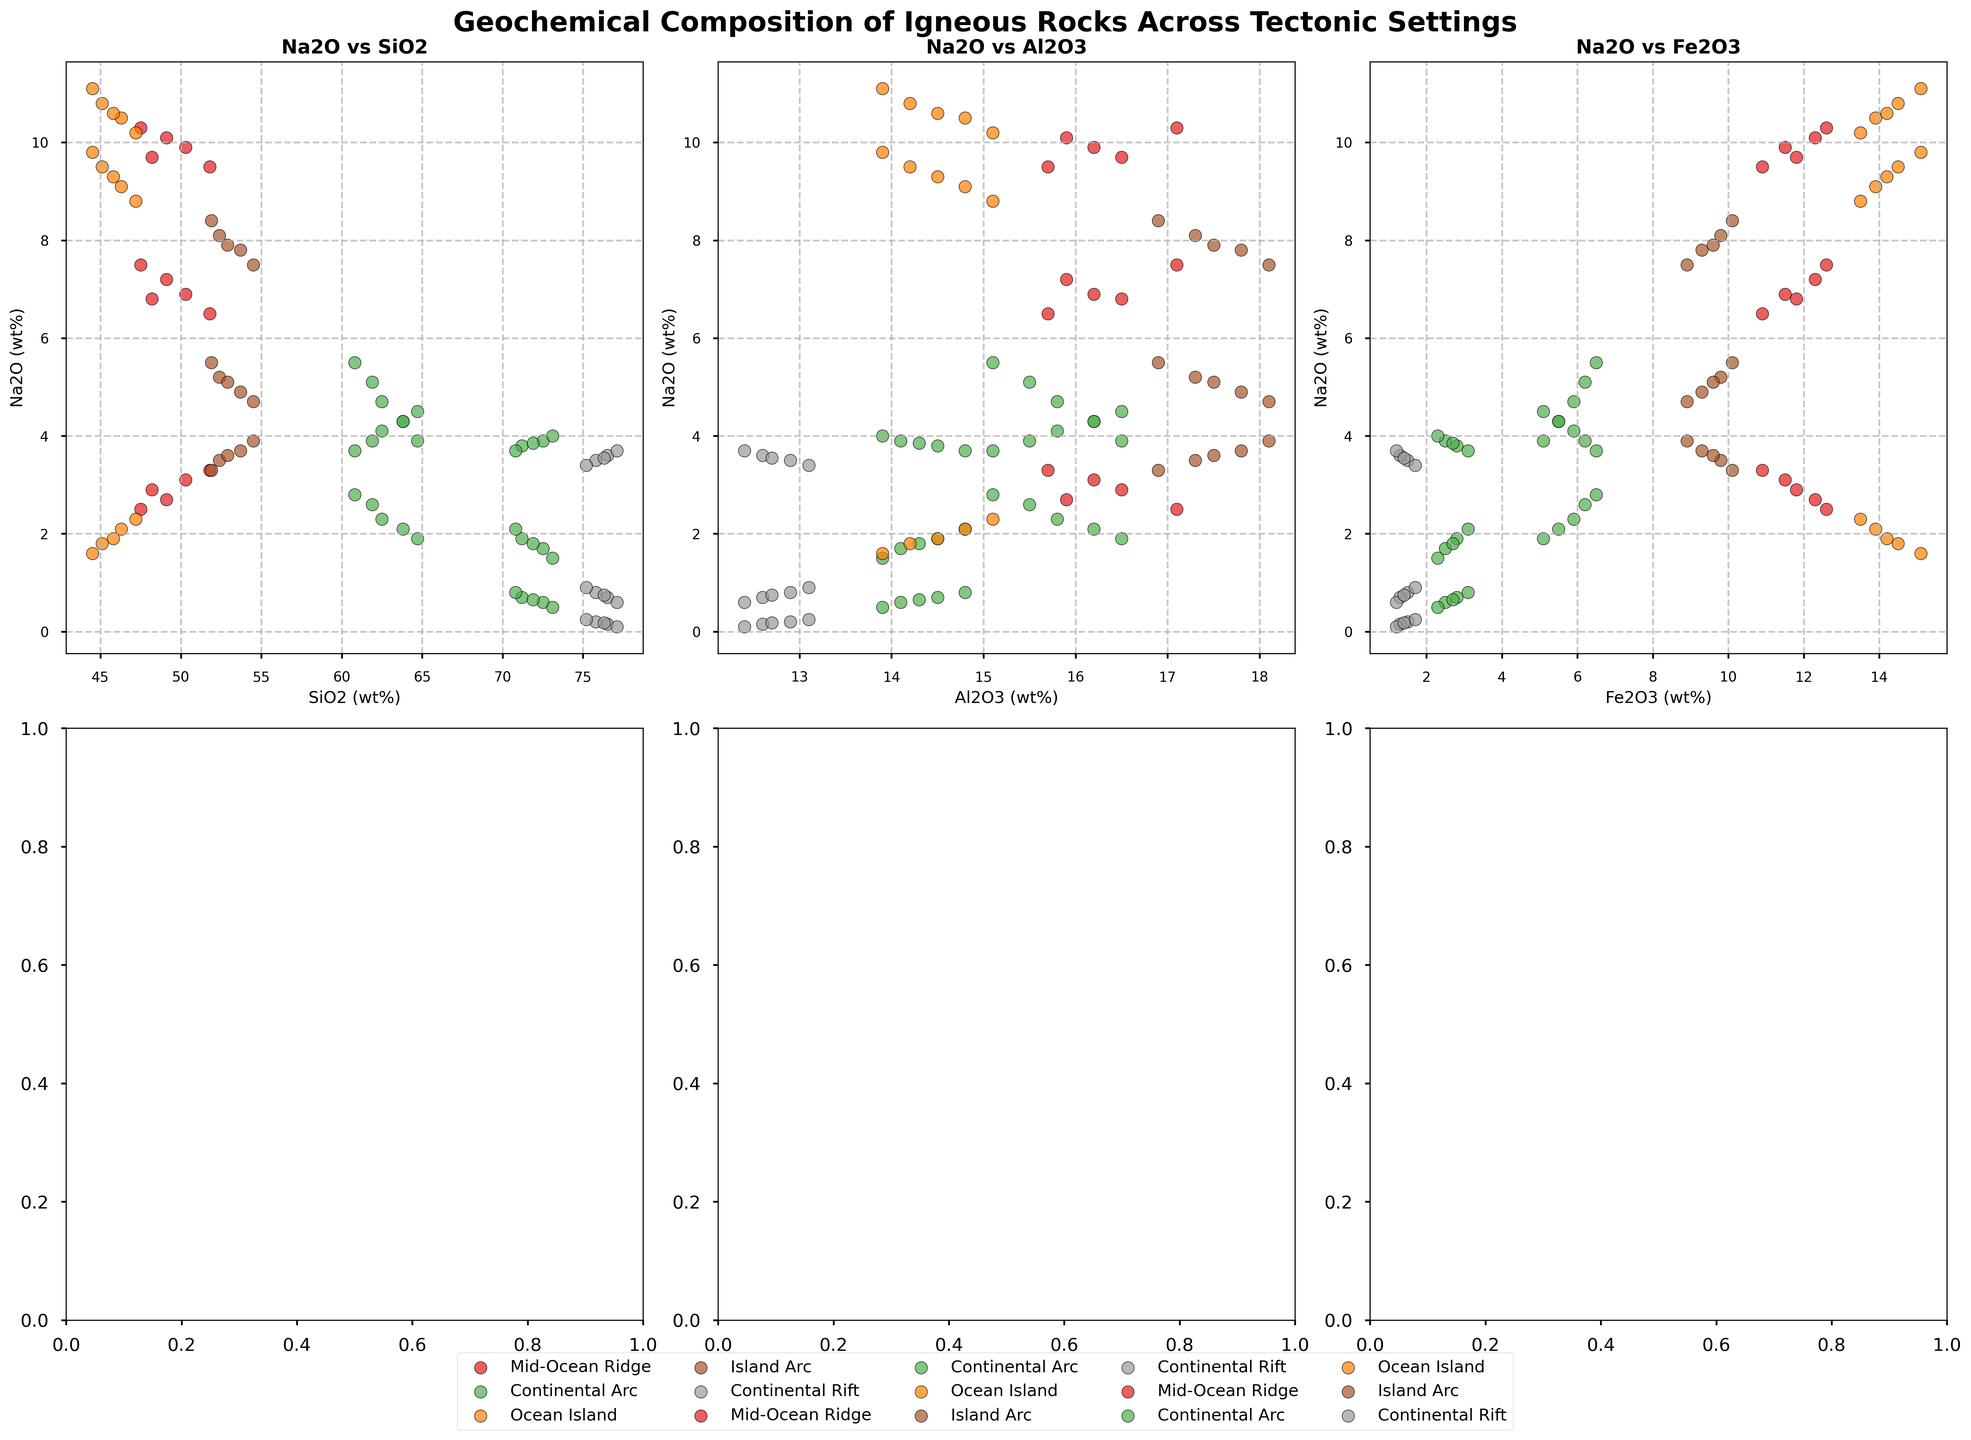What are the average values of SiO2 and Na2O in the Mid-Ocean Ridge setting? First, find the values of SiO2 and Na2O in the Mid-Ocean Ridge setting: SiO2 = [48.2, 49.1, 50.3, 51.8, 47.5], Na2O = [2.9, 2.7, 3.1, 3.3, 2.5]. Compute the average SiO2: (48.2 + 49.1 + 50.3 + 51.8 + 47.5) / 5 = 49.38. Compute the average Na2O: (2.9 + 2.7 + 3.1 + 3.3 + 2.5) / 5 = 2.9.
Answer: 49.38 and 2.9 Which setting shows the highest concentration of SiO2? Compare the central positions of the SiO2 values across different settings. Continental Rift and Continental Arc settings range between 60 and 77, while others have lower maximals.
Answer: Continental Rift In the SiO2 vs. MgO subplot, which setting generally has the lowest MgO content? Look at the MgO axis in the SiO2 vs. MgO subplot. The points with the lowest MgO values (<1) are from the Continental Rift setting.
Answer: Continental Rift Between the Island Arc and Ocean Island settings, which one has more varying values of CaO in the SiO2 vs. CaO plot? Check the spread of points along the CaO axis. The Ocean Island setting shows a larger spread in CaO values (from 10 to approx. 12).
Answer: Ocean Island Which setting has the most clustering in the Fe2O3 vs. CaO subplot? Observe which setting has the least dispersed points in the Fe2O3 vs. CaO plot. The Continental Arc appears to have closely clustered points.
Answer: Continental Arc How do the SiO2 values in the Island Arc setting compare to those in the Mid-Ocean Ridge setting? Compare the general range of SiO2 values for both settings. Island Arc values (~52 to 54.5) are generally higher compared to Mid-Ocean Ridge values (~47.5 to 51.8).
Answer: Higher Do the Na2O values of the Continental Arc and Rhyolite rock type overlap in the plots presented? By examining the Na2O values for both Rhyolite and Continental Arc groupings, there seems to be an overlap with Rhyolite ranging from approx. 3.4 to 4.9, and Continental Arc in the same range.
Answer: Yes Is there any significant variation in the CaO values between the settings in the Fe2O3 vs. CaO subplot? Check the variation along the CaO axis. Ocean Island and Mid-Ocean Ridge show the highest variation around 9-10 for CaO values, while others are below that.
Answer: Yes Which plot shows the least amount of overlap between different settings? Observe all the subplots. The Fe2O3 vs. CaO subplot demonstrates less overlap, particularly with different settings grouping in distinct areas.
Answer: Fe2O3 vs. CaO 